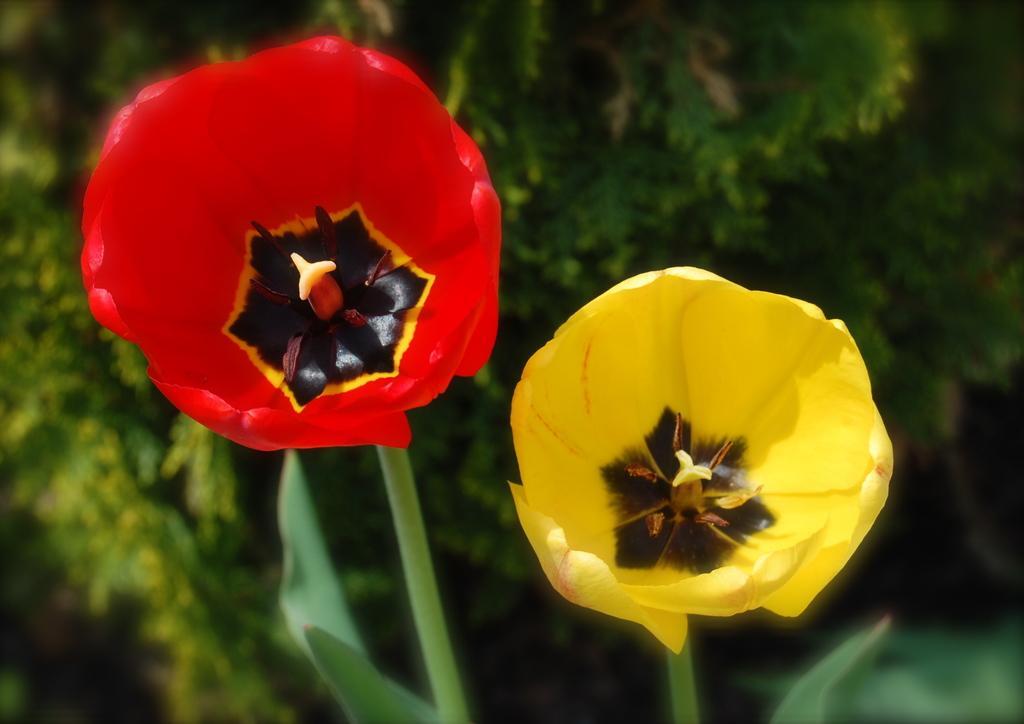How would you summarize this image in a sentence or two? In this image on the right side, I can see a yellow flower. On the left side I can see a red flower. I can see the background is green in color. 